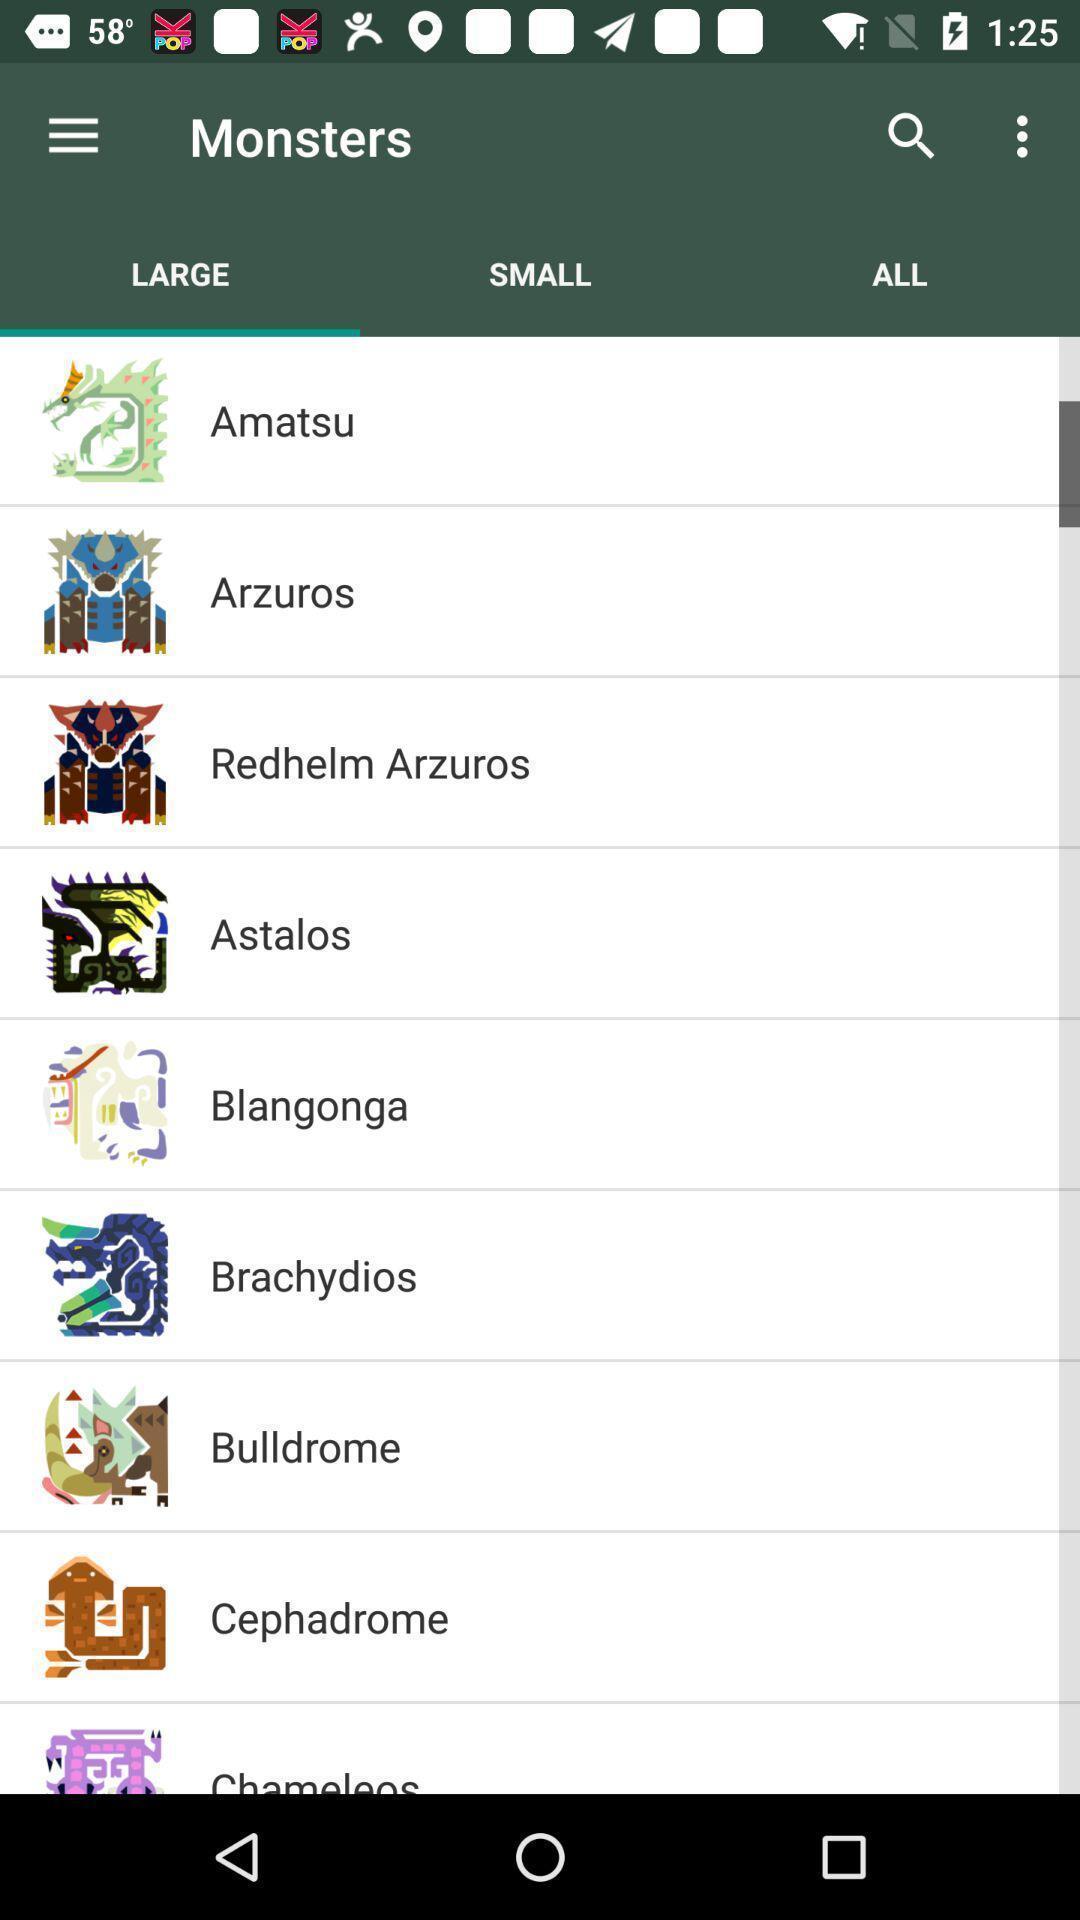Provide a detailed account of this screenshot. Page showing large monsters. 